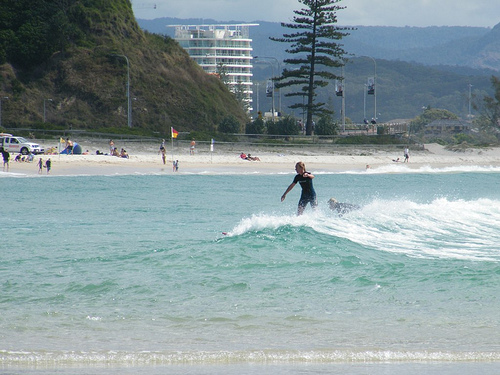Please provide the bounding box coordinate of the region this sentence describes: flag in the sand. The bounding box coordinates for the flag in the sand are [0.32, 0.37, 0.36, 0.44]. These coordinates indicate where a flag is positioned in the sandy area of the beach. 